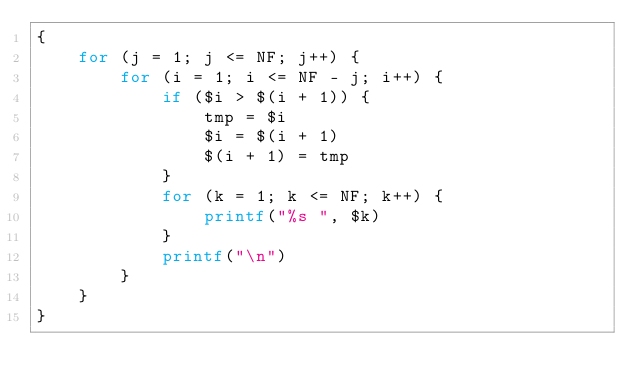Convert code to text. <code><loc_0><loc_0><loc_500><loc_500><_Awk_>{
    for (j = 1; j <= NF; j++) {
        for (i = 1; i <= NF - j; i++) {
            if ($i > $(i + 1)) {
                tmp = $i
                $i = $(i + 1)
                $(i + 1) = tmp
            }
            for (k = 1; k <= NF; k++) {
                printf("%s ", $k)
            }
            printf("\n")
        }
    }
}
</code> 